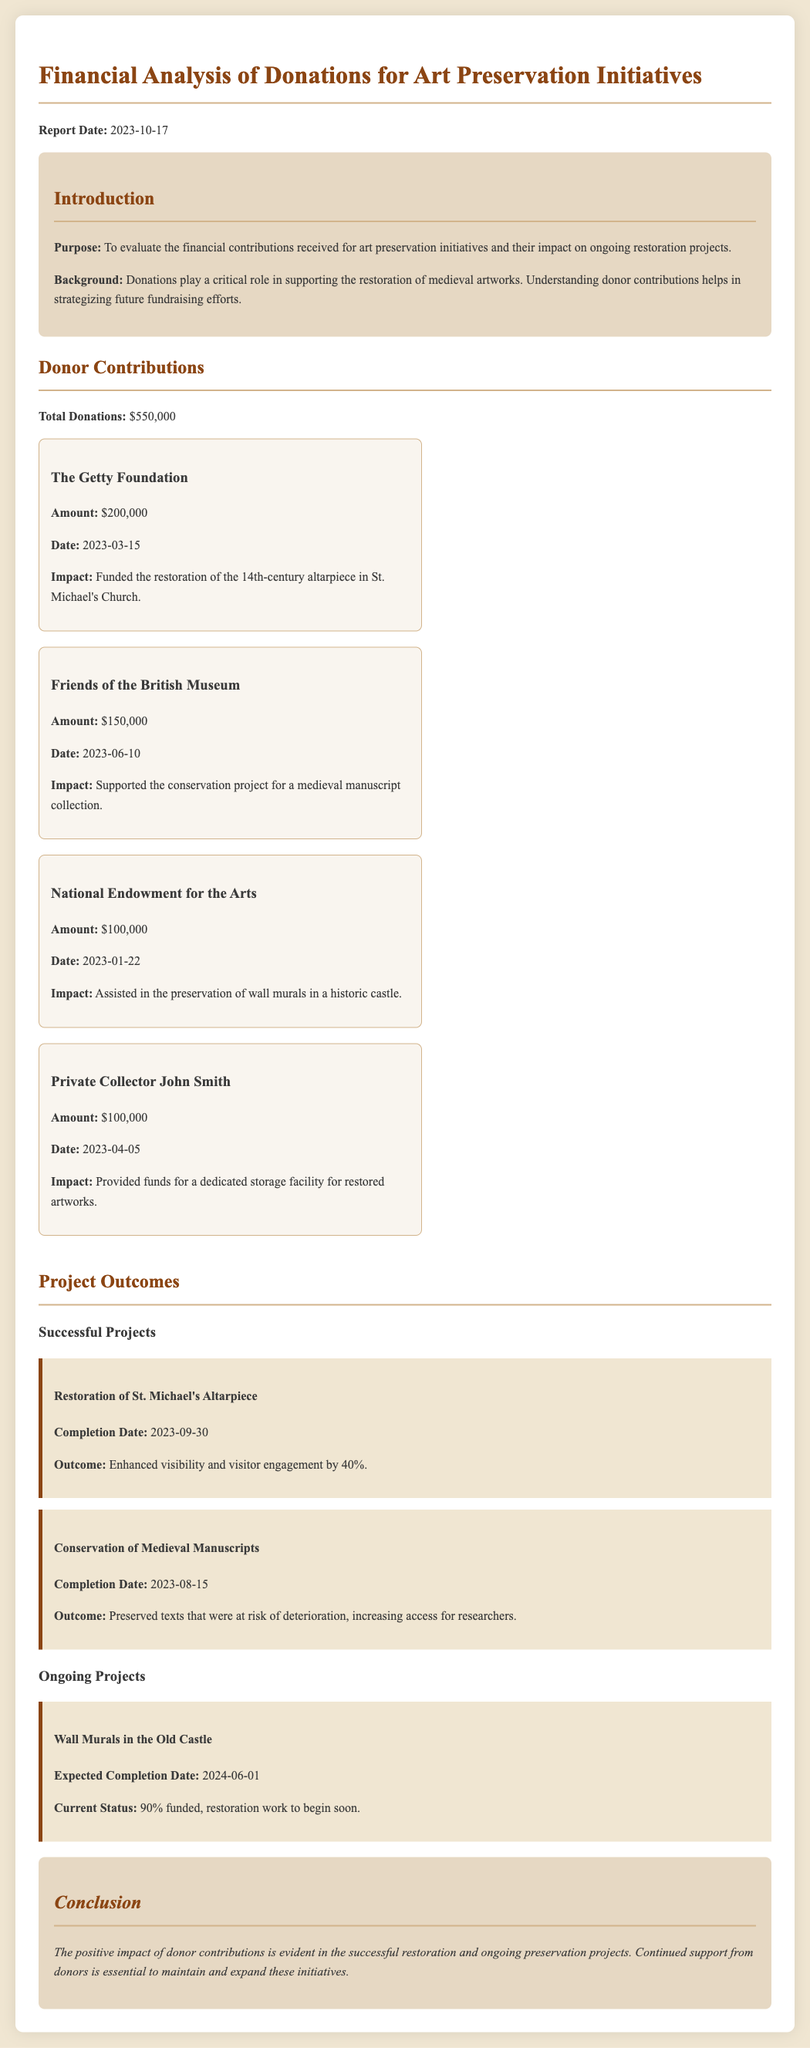What is the total amount of donations? The total amount of donations is explicitly stated in the report as $550,000.
Answer: $550,000 Who funded the restoration of the 14th-century altarpiece? According to the document, the Getty Foundation funded the restoration of the 14th-century altarpiece.
Answer: The Getty Foundation When was the donation from Friends of the British Museum made? The date of the donation made by Friends of the British Museum is provided as June 10, 2023.
Answer: 2023-06-10 What percentage of funding is completed for the Wall Murals project? The document states that the Wall Murals project is 90% funded at this time.
Answer: 90% What was the outcome of the restoration of St. Michael's Altarpiece? The report indicates that the outcome was enhanced visibility and visitor engagement by 40%.
Answer: Increased by 40% What is the expected completion date for the Wall Murals project? The expected completion date for the Wall Murals project is given as June 1, 2024.
Answer: 2024-06-01 How much did Private Collector John Smith contribute? The contribution from Private Collector John Smith is mentioned as $100,000.
Answer: $100,000 What is the main purpose of the report? The report clearly states that its purpose is to evaluate financial contributions for art preservation initiatives.
Answer: Evaluate financial contributions 